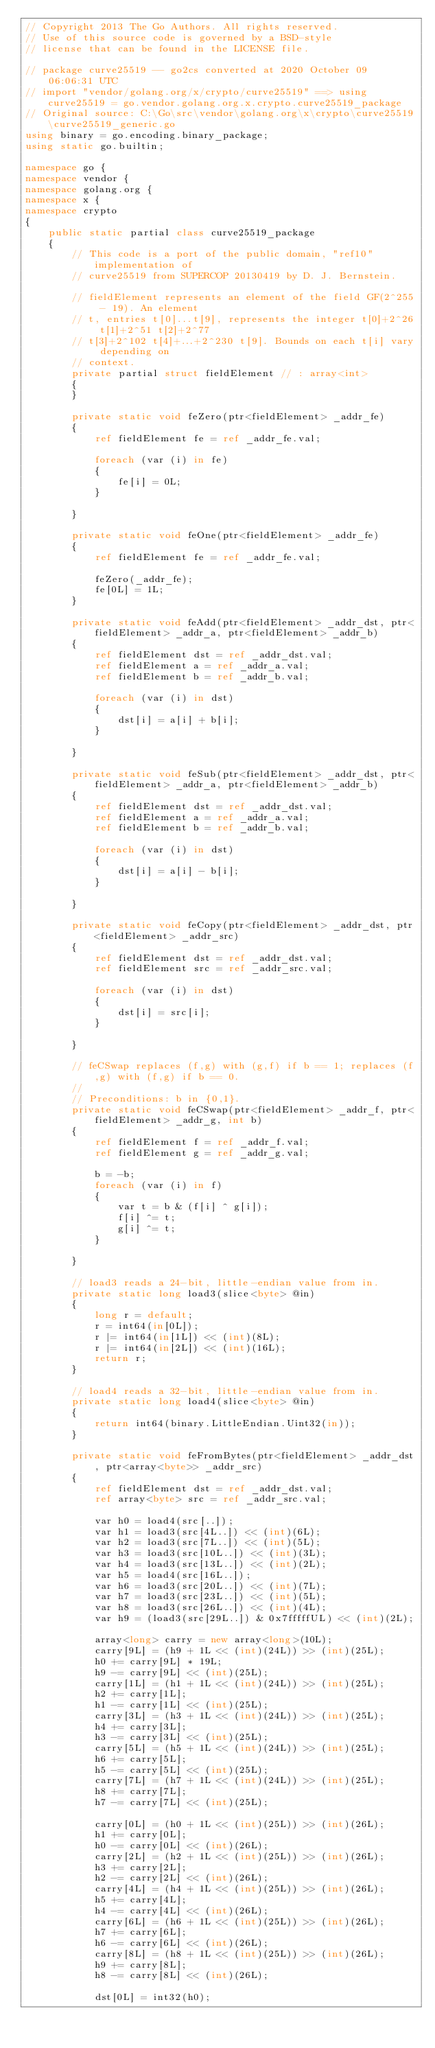Convert code to text. <code><loc_0><loc_0><loc_500><loc_500><_C#_>// Copyright 2013 The Go Authors. All rights reserved.
// Use of this source code is governed by a BSD-style
// license that can be found in the LICENSE file.

// package curve25519 -- go2cs converted at 2020 October 09 06:06:31 UTC
// import "vendor/golang.org/x/crypto/curve25519" ==> using curve25519 = go.vendor.golang.org.x.crypto.curve25519_package
// Original source: C:\Go\src\vendor\golang.org\x\crypto\curve25519\curve25519_generic.go
using binary = go.encoding.binary_package;
using static go.builtin;

namespace go {
namespace vendor {
namespace golang.org {
namespace x {
namespace crypto
{
    public static partial class curve25519_package
    {
        // This code is a port of the public domain, "ref10" implementation of
        // curve25519 from SUPERCOP 20130419 by D. J. Bernstein.

        // fieldElement represents an element of the field GF(2^255 - 19). An element
        // t, entries t[0]...t[9], represents the integer t[0]+2^26 t[1]+2^51 t[2]+2^77
        // t[3]+2^102 t[4]+...+2^230 t[9]. Bounds on each t[i] vary depending on
        // context.
        private partial struct fieldElement // : array<int>
        {
        }

        private static void feZero(ptr<fieldElement> _addr_fe)
        {
            ref fieldElement fe = ref _addr_fe.val;

            foreach (var (i) in fe)
            {
                fe[i] = 0L;
            }

        }

        private static void feOne(ptr<fieldElement> _addr_fe)
        {
            ref fieldElement fe = ref _addr_fe.val;

            feZero(_addr_fe);
            fe[0L] = 1L;
        }

        private static void feAdd(ptr<fieldElement> _addr_dst, ptr<fieldElement> _addr_a, ptr<fieldElement> _addr_b)
        {
            ref fieldElement dst = ref _addr_dst.val;
            ref fieldElement a = ref _addr_a.val;
            ref fieldElement b = ref _addr_b.val;

            foreach (var (i) in dst)
            {
                dst[i] = a[i] + b[i];
            }

        }

        private static void feSub(ptr<fieldElement> _addr_dst, ptr<fieldElement> _addr_a, ptr<fieldElement> _addr_b)
        {
            ref fieldElement dst = ref _addr_dst.val;
            ref fieldElement a = ref _addr_a.val;
            ref fieldElement b = ref _addr_b.val;

            foreach (var (i) in dst)
            {
                dst[i] = a[i] - b[i];
            }

        }

        private static void feCopy(ptr<fieldElement> _addr_dst, ptr<fieldElement> _addr_src)
        {
            ref fieldElement dst = ref _addr_dst.val;
            ref fieldElement src = ref _addr_src.val;

            foreach (var (i) in dst)
            {
                dst[i] = src[i];
            }

        }

        // feCSwap replaces (f,g) with (g,f) if b == 1; replaces (f,g) with (f,g) if b == 0.
        //
        // Preconditions: b in {0,1}.
        private static void feCSwap(ptr<fieldElement> _addr_f, ptr<fieldElement> _addr_g, int b)
        {
            ref fieldElement f = ref _addr_f.val;
            ref fieldElement g = ref _addr_g.val;

            b = -b;
            foreach (var (i) in f)
            {
                var t = b & (f[i] ^ g[i]);
                f[i] ^= t;
                g[i] ^= t;
            }

        }

        // load3 reads a 24-bit, little-endian value from in.
        private static long load3(slice<byte> @in)
        {
            long r = default;
            r = int64(in[0L]);
            r |= int64(in[1L]) << (int)(8L);
            r |= int64(in[2L]) << (int)(16L);
            return r;
        }

        // load4 reads a 32-bit, little-endian value from in.
        private static long load4(slice<byte> @in)
        {
            return int64(binary.LittleEndian.Uint32(in));
        }

        private static void feFromBytes(ptr<fieldElement> _addr_dst, ptr<array<byte>> _addr_src)
        {
            ref fieldElement dst = ref _addr_dst.val;
            ref array<byte> src = ref _addr_src.val;

            var h0 = load4(src[..]);
            var h1 = load3(src[4L..]) << (int)(6L);
            var h2 = load3(src[7L..]) << (int)(5L);
            var h3 = load3(src[10L..]) << (int)(3L);
            var h4 = load3(src[13L..]) << (int)(2L);
            var h5 = load4(src[16L..]);
            var h6 = load3(src[20L..]) << (int)(7L);
            var h7 = load3(src[23L..]) << (int)(5L);
            var h8 = load3(src[26L..]) << (int)(4L);
            var h9 = (load3(src[29L..]) & 0x7fffffUL) << (int)(2L);

            array<long> carry = new array<long>(10L);
            carry[9L] = (h9 + 1L << (int)(24L)) >> (int)(25L);
            h0 += carry[9L] * 19L;
            h9 -= carry[9L] << (int)(25L);
            carry[1L] = (h1 + 1L << (int)(24L)) >> (int)(25L);
            h2 += carry[1L];
            h1 -= carry[1L] << (int)(25L);
            carry[3L] = (h3 + 1L << (int)(24L)) >> (int)(25L);
            h4 += carry[3L];
            h3 -= carry[3L] << (int)(25L);
            carry[5L] = (h5 + 1L << (int)(24L)) >> (int)(25L);
            h6 += carry[5L];
            h5 -= carry[5L] << (int)(25L);
            carry[7L] = (h7 + 1L << (int)(24L)) >> (int)(25L);
            h8 += carry[7L];
            h7 -= carry[7L] << (int)(25L);

            carry[0L] = (h0 + 1L << (int)(25L)) >> (int)(26L);
            h1 += carry[0L];
            h0 -= carry[0L] << (int)(26L);
            carry[2L] = (h2 + 1L << (int)(25L)) >> (int)(26L);
            h3 += carry[2L];
            h2 -= carry[2L] << (int)(26L);
            carry[4L] = (h4 + 1L << (int)(25L)) >> (int)(26L);
            h5 += carry[4L];
            h4 -= carry[4L] << (int)(26L);
            carry[6L] = (h6 + 1L << (int)(25L)) >> (int)(26L);
            h7 += carry[6L];
            h6 -= carry[6L] << (int)(26L);
            carry[8L] = (h8 + 1L << (int)(25L)) >> (int)(26L);
            h9 += carry[8L];
            h8 -= carry[8L] << (int)(26L);

            dst[0L] = int32(h0);</code> 